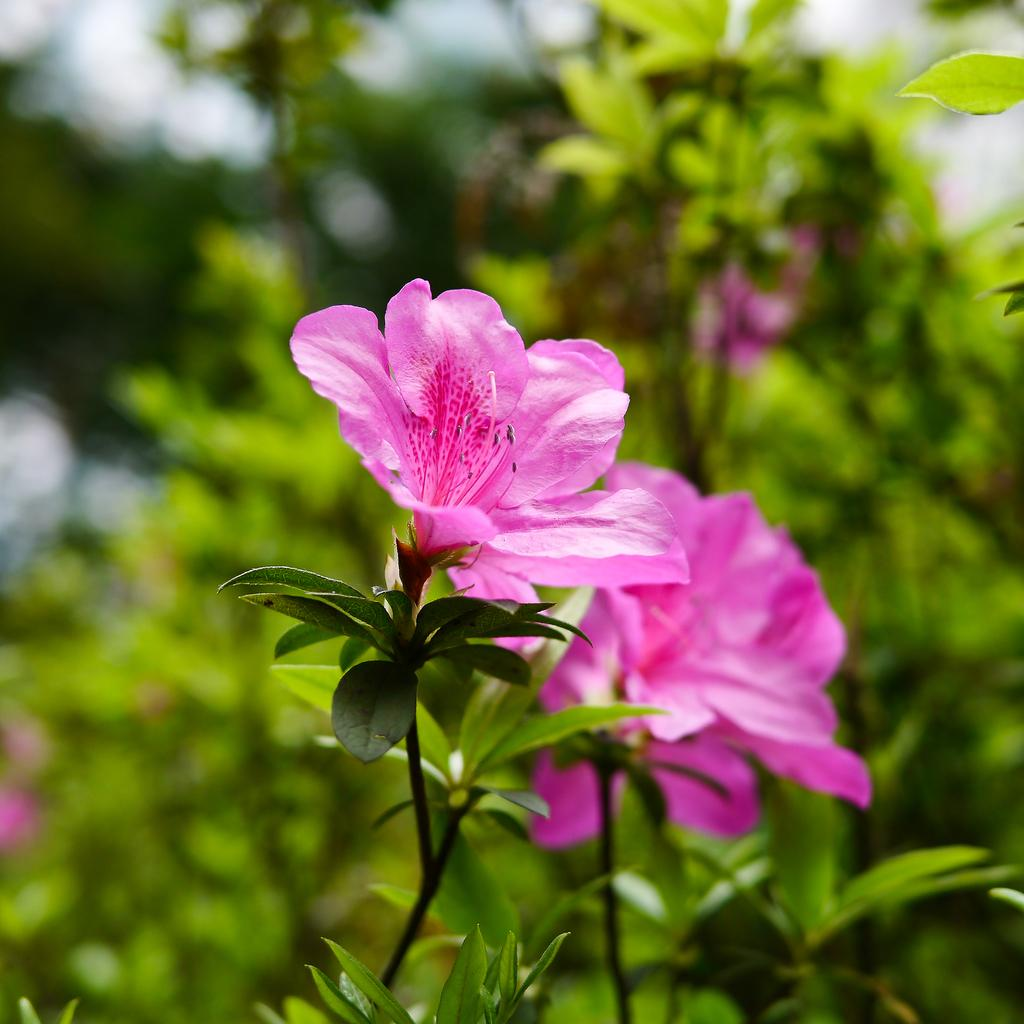What type of plants can be seen in the image? There are pink flower plants in the image. How many zebras are grazing near the pink flower plants in the image? There are no zebras present in the image; it only features pink flower plants. 